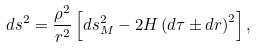<formula> <loc_0><loc_0><loc_500><loc_500>d s ^ { 2 } = \frac { { \rho } ^ { 2 } } { r ^ { 2 } } \left [ d s ^ { 2 } _ { M } - 2 H \left ( d \tau \pm d r \right ) ^ { 2 } \right ] ,</formula> 